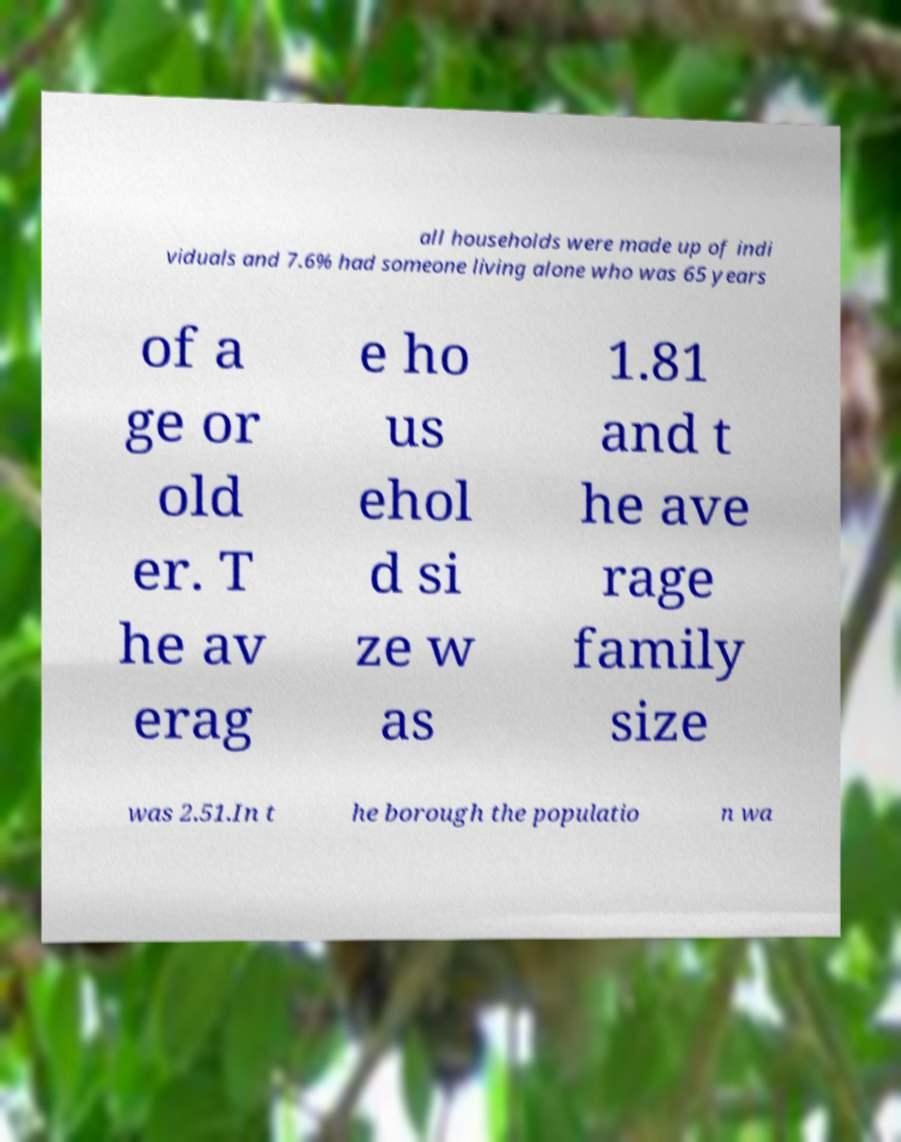Please read and relay the text visible in this image. What does it say? all households were made up of indi viduals and 7.6% had someone living alone who was 65 years of a ge or old er. T he av erag e ho us ehol d si ze w as 1.81 and t he ave rage family size was 2.51.In t he borough the populatio n wa 